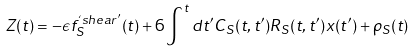Convert formula to latex. <formula><loc_0><loc_0><loc_500><loc_500>Z ( t ) = - \epsilon f ^ { ` s h e a r ^ { \prime } } _ { S } ( t ) + 6 \int ^ { t } d t ^ { \prime } C _ { S } ( t , t ^ { \prime } ) R _ { S } ( t , t ^ { \prime } ) x ( t ^ { \prime } ) + \rho _ { S } ( t )</formula> 